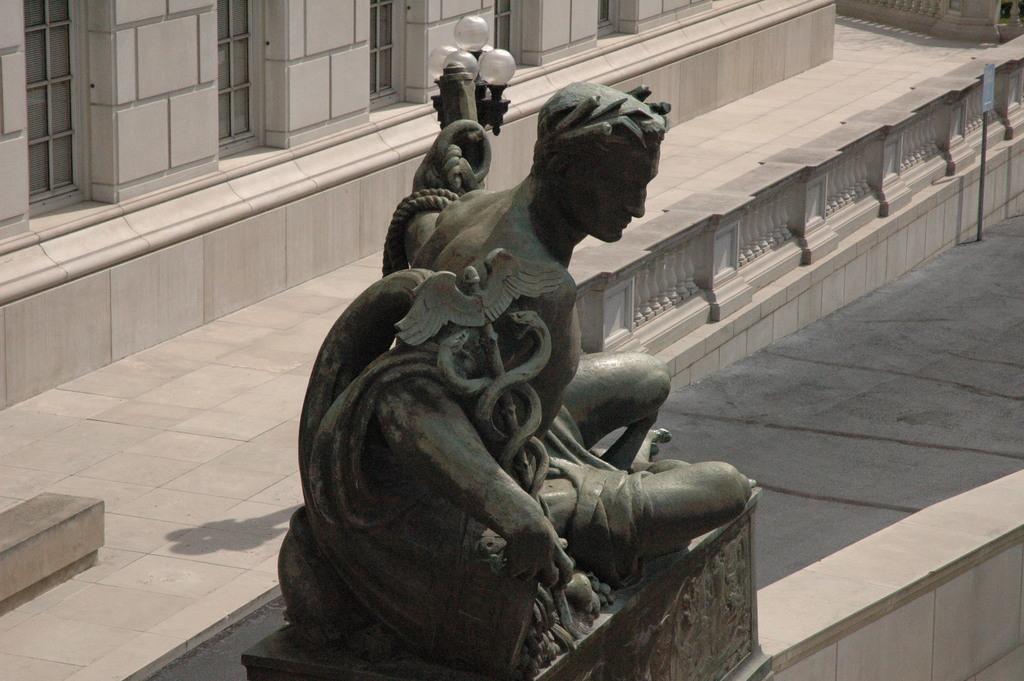Please provide a concise description of this image. In this image, in the middle, we can see a sculpture. In the background, we can see a building and a glass window. 